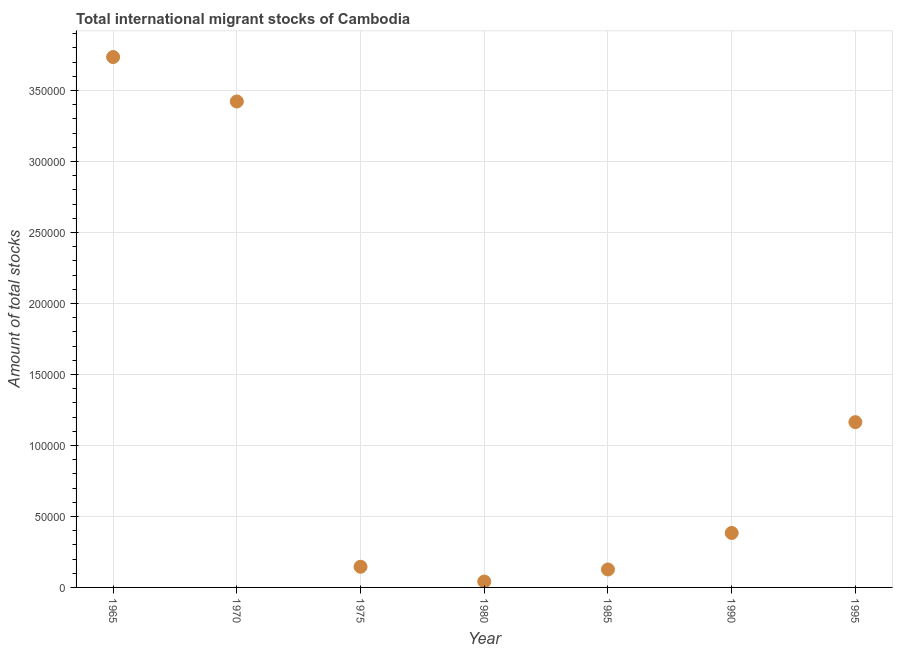What is the total number of international migrant stock in 1995?
Your answer should be very brief. 1.16e+05. Across all years, what is the maximum total number of international migrant stock?
Your response must be concise. 3.74e+05. Across all years, what is the minimum total number of international migrant stock?
Keep it short and to the point. 4168. In which year was the total number of international migrant stock maximum?
Ensure brevity in your answer.  1965. What is the sum of the total number of international migrant stock?
Keep it short and to the point. 9.02e+05. What is the difference between the total number of international migrant stock in 1990 and 1995?
Keep it short and to the point. -7.81e+04. What is the average total number of international migrant stock per year?
Offer a terse response. 1.29e+05. What is the median total number of international migrant stock?
Offer a very short reply. 3.84e+04. In how many years, is the total number of international migrant stock greater than 190000 ?
Make the answer very short. 2. What is the ratio of the total number of international migrant stock in 1965 to that in 1995?
Your response must be concise. 3.21. Is the total number of international migrant stock in 1965 less than that in 1990?
Make the answer very short. No. Is the difference between the total number of international migrant stock in 1975 and 1980 greater than the difference between any two years?
Your answer should be compact. No. What is the difference between the highest and the second highest total number of international migrant stock?
Your answer should be compact. 3.13e+04. What is the difference between the highest and the lowest total number of international migrant stock?
Keep it short and to the point. 3.69e+05. How many dotlines are there?
Make the answer very short. 1. How many years are there in the graph?
Ensure brevity in your answer.  7. Are the values on the major ticks of Y-axis written in scientific E-notation?
Give a very brief answer. No. What is the title of the graph?
Give a very brief answer. Total international migrant stocks of Cambodia. What is the label or title of the Y-axis?
Your answer should be compact. Amount of total stocks. What is the Amount of total stocks in 1965?
Give a very brief answer. 3.74e+05. What is the Amount of total stocks in 1970?
Provide a short and direct response. 3.42e+05. What is the Amount of total stocks in 1975?
Your response must be concise. 1.46e+04. What is the Amount of total stocks in 1980?
Provide a succinct answer. 4168. What is the Amount of total stocks in 1985?
Your response must be concise. 1.26e+04. What is the Amount of total stocks in 1990?
Your answer should be compact. 3.84e+04. What is the Amount of total stocks in 1995?
Keep it short and to the point. 1.16e+05. What is the difference between the Amount of total stocks in 1965 and 1970?
Give a very brief answer. 3.13e+04. What is the difference between the Amount of total stocks in 1965 and 1975?
Make the answer very short. 3.59e+05. What is the difference between the Amount of total stocks in 1965 and 1980?
Provide a short and direct response. 3.69e+05. What is the difference between the Amount of total stocks in 1965 and 1985?
Make the answer very short. 3.61e+05. What is the difference between the Amount of total stocks in 1965 and 1990?
Ensure brevity in your answer.  3.35e+05. What is the difference between the Amount of total stocks in 1965 and 1995?
Keep it short and to the point. 2.57e+05. What is the difference between the Amount of total stocks in 1970 and 1975?
Ensure brevity in your answer.  3.28e+05. What is the difference between the Amount of total stocks in 1970 and 1980?
Provide a short and direct response. 3.38e+05. What is the difference between the Amount of total stocks in 1970 and 1985?
Your answer should be compact. 3.30e+05. What is the difference between the Amount of total stocks in 1970 and 1990?
Ensure brevity in your answer.  3.04e+05. What is the difference between the Amount of total stocks in 1970 and 1995?
Your response must be concise. 2.26e+05. What is the difference between the Amount of total stocks in 1975 and 1980?
Give a very brief answer. 1.04e+04. What is the difference between the Amount of total stocks in 1975 and 1985?
Offer a very short reply. 1904. What is the difference between the Amount of total stocks in 1975 and 1990?
Your answer should be very brief. -2.38e+04. What is the difference between the Amount of total stocks in 1975 and 1995?
Provide a short and direct response. -1.02e+05. What is the difference between the Amount of total stocks in 1980 and 1985?
Make the answer very short. -8479. What is the difference between the Amount of total stocks in 1980 and 1990?
Make the answer very short. -3.42e+04. What is the difference between the Amount of total stocks in 1980 and 1995?
Keep it short and to the point. -1.12e+05. What is the difference between the Amount of total stocks in 1985 and 1990?
Provide a short and direct response. -2.57e+04. What is the difference between the Amount of total stocks in 1985 and 1995?
Your response must be concise. -1.04e+05. What is the difference between the Amount of total stocks in 1990 and 1995?
Offer a terse response. -7.81e+04. What is the ratio of the Amount of total stocks in 1965 to that in 1970?
Your answer should be very brief. 1.09. What is the ratio of the Amount of total stocks in 1965 to that in 1975?
Provide a short and direct response. 25.68. What is the ratio of the Amount of total stocks in 1965 to that in 1980?
Provide a succinct answer. 89.64. What is the ratio of the Amount of total stocks in 1965 to that in 1985?
Your answer should be very brief. 29.54. What is the ratio of the Amount of total stocks in 1965 to that in 1990?
Make the answer very short. 9.74. What is the ratio of the Amount of total stocks in 1965 to that in 1995?
Give a very brief answer. 3.21. What is the ratio of the Amount of total stocks in 1970 to that in 1975?
Your answer should be compact. 23.53. What is the ratio of the Amount of total stocks in 1970 to that in 1980?
Ensure brevity in your answer.  82.13. What is the ratio of the Amount of total stocks in 1970 to that in 1985?
Offer a terse response. 27.07. What is the ratio of the Amount of total stocks in 1970 to that in 1990?
Your answer should be very brief. 8.92. What is the ratio of the Amount of total stocks in 1970 to that in 1995?
Your response must be concise. 2.94. What is the ratio of the Amount of total stocks in 1975 to that in 1980?
Your answer should be compact. 3.49. What is the ratio of the Amount of total stocks in 1975 to that in 1985?
Offer a very short reply. 1.15. What is the ratio of the Amount of total stocks in 1975 to that in 1990?
Provide a short and direct response. 0.38. What is the ratio of the Amount of total stocks in 1975 to that in 1995?
Keep it short and to the point. 0.12. What is the ratio of the Amount of total stocks in 1980 to that in 1985?
Offer a terse response. 0.33. What is the ratio of the Amount of total stocks in 1980 to that in 1990?
Provide a short and direct response. 0.11. What is the ratio of the Amount of total stocks in 1980 to that in 1995?
Offer a very short reply. 0.04. What is the ratio of the Amount of total stocks in 1985 to that in 1990?
Give a very brief answer. 0.33. What is the ratio of the Amount of total stocks in 1985 to that in 1995?
Make the answer very short. 0.11. What is the ratio of the Amount of total stocks in 1990 to that in 1995?
Your answer should be compact. 0.33. 